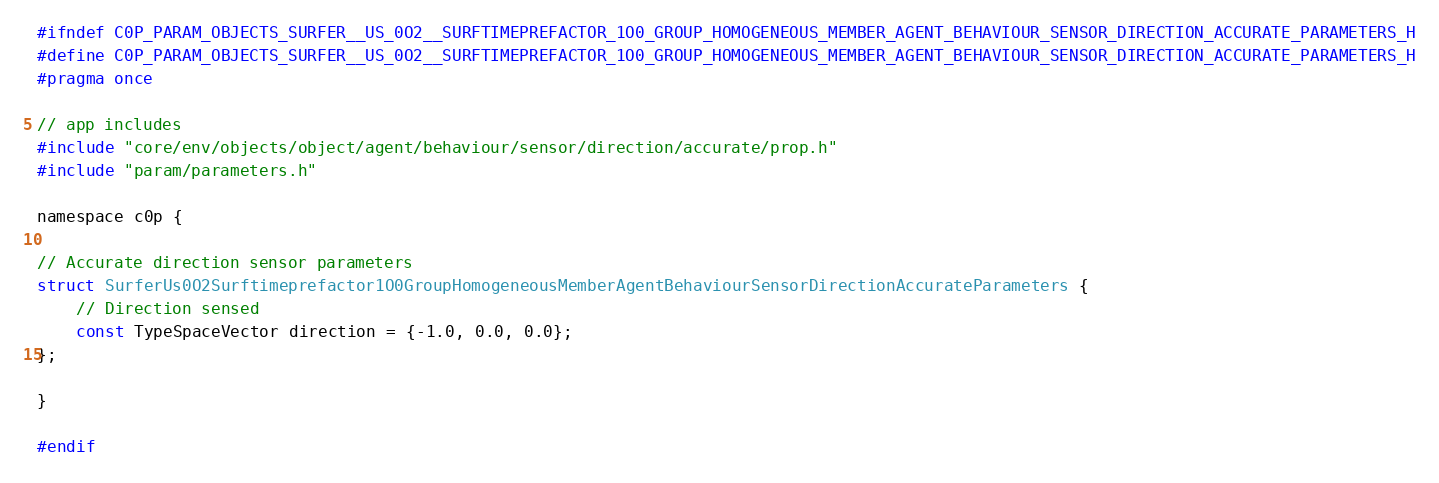<code> <loc_0><loc_0><loc_500><loc_500><_C_>#ifndef C0P_PARAM_OBJECTS_SURFER__US_0O2__SURFTIMEPREFACTOR_1O0_GROUP_HOMOGENEOUS_MEMBER_AGENT_BEHAVIOUR_SENSOR_DIRECTION_ACCURATE_PARAMETERS_H
#define C0P_PARAM_OBJECTS_SURFER__US_0O2__SURFTIMEPREFACTOR_1O0_GROUP_HOMOGENEOUS_MEMBER_AGENT_BEHAVIOUR_SENSOR_DIRECTION_ACCURATE_PARAMETERS_H
#pragma once

// app includes
#include "core/env/objects/object/agent/behaviour/sensor/direction/accurate/prop.h"
#include "param/parameters.h"

namespace c0p {

// Accurate direction sensor parameters
struct SurferUs0O2Surftimeprefactor1O0GroupHomogeneousMemberAgentBehaviourSensorDirectionAccurateParameters {
    // Direction sensed
    const TypeSpaceVector direction = {-1.0, 0.0, 0.0};
};

}

#endif
</code> 